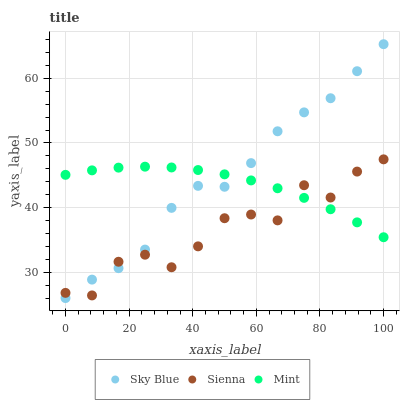Does Sienna have the minimum area under the curve?
Answer yes or no. Yes. Does Sky Blue have the maximum area under the curve?
Answer yes or no. Yes. Does Mint have the minimum area under the curve?
Answer yes or no. No. Does Mint have the maximum area under the curve?
Answer yes or no. No. Is Mint the smoothest?
Answer yes or no. Yes. Is Sienna the roughest?
Answer yes or no. Yes. Is Sky Blue the smoothest?
Answer yes or no. No. Is Sky Blue the roughest?
Answer yes or no. No. Does Sky Blue have the lowest value?
Answer yes or no. Yes. Does Mint have the lowest value?
Answer yes or no. No. Does Sky Blue have the highest value?
Answer yes or no. Yes. Does Mint have the highest value?
Answer yes or no. No. Does Sky Blue intersect Mint?
Answer yes or no. Yes. Is Sky Blue less than Mint?
Answer yes or no. No. Is Sky Blue greater than Mint?
Answer yes or no. No. 